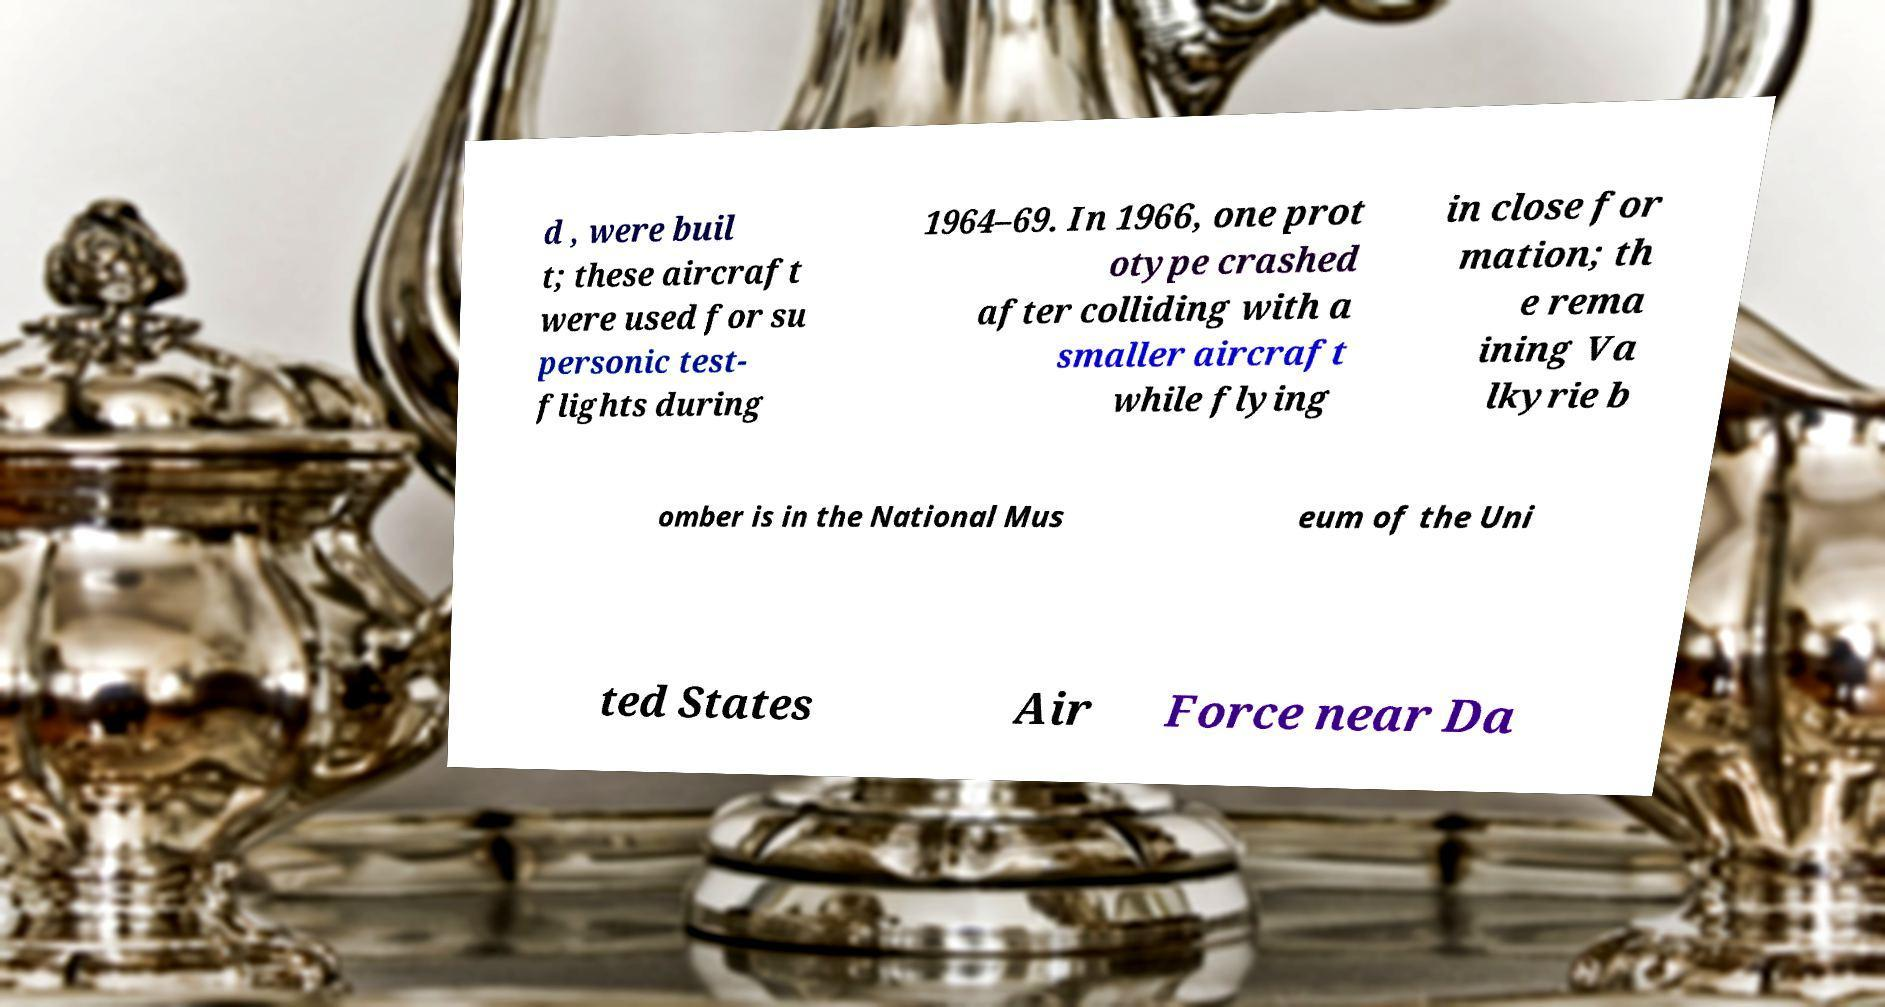For documentation purposes, I need the text within this image transcribed. Could you provide that? d , were buil t; these aircraft were used for su personic test- flights during 1964–69. In 1966, one prot otype crashed after colliding with a smaller aircraft while flying in close for mation; th e rema ining Va lkyrie b omber is in the National Mus eum of the Uni ted States Air Force near Da 